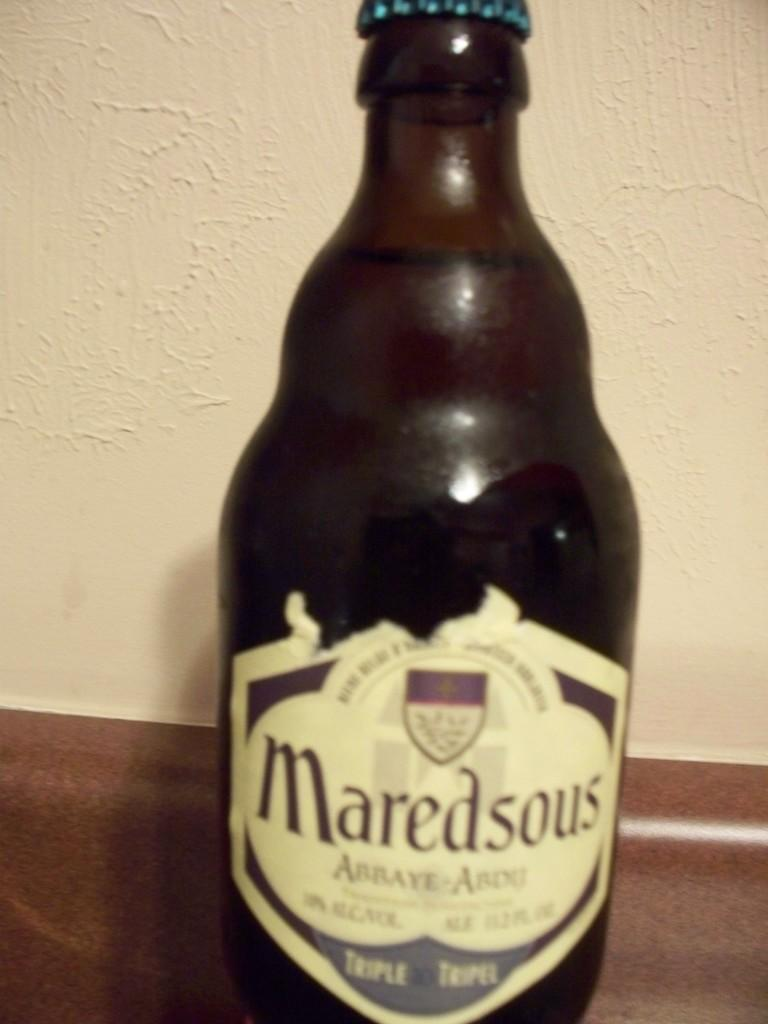<image>
Provide a brief description of the given image. Maredsous alcohol that is new and sitting on a counter 